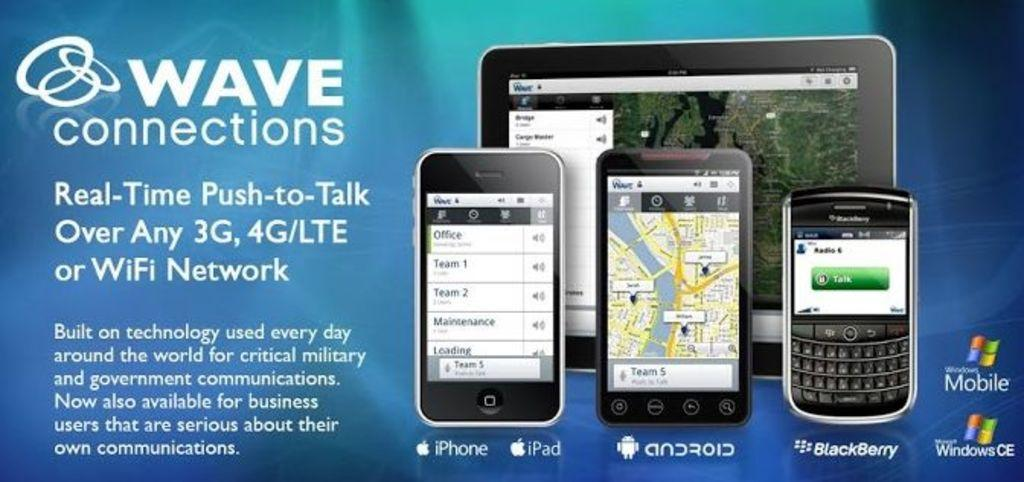Provide a one-sentence caption for the provided image. Picture of three cellphones and a ipad from wave connections. 